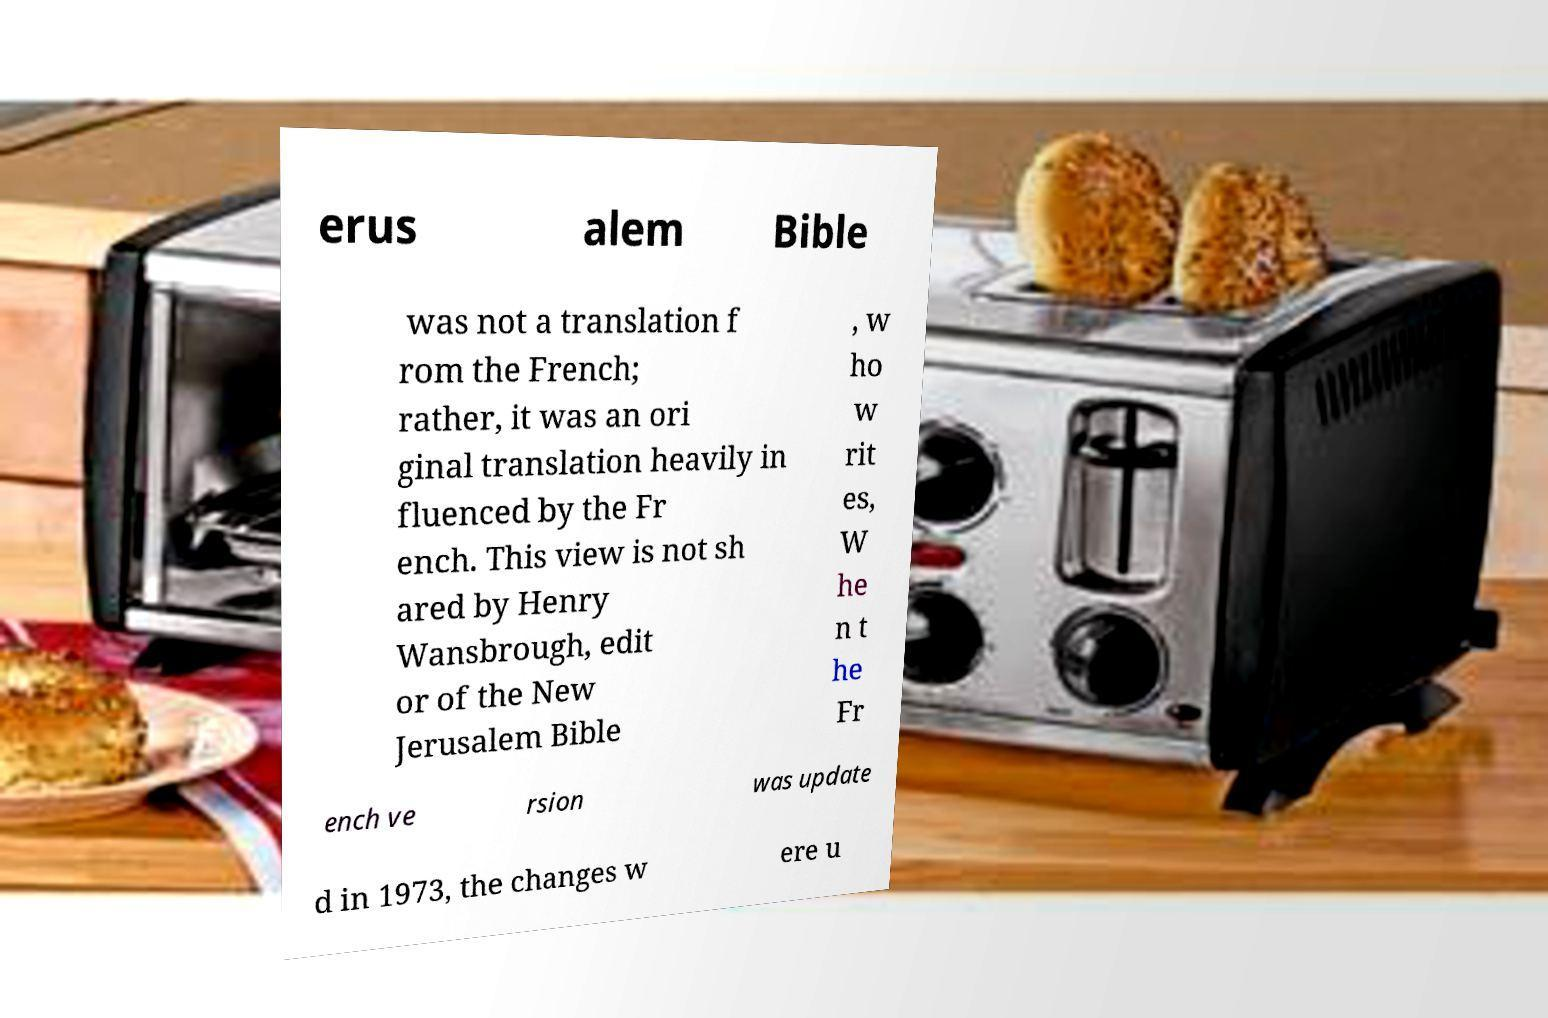Can you accurately transcribe the text from the provided image for me? erus alem Bible was not a translation f rom the French; rather, it was an ori ginal translation heavily in fluenced by the Fr ench. This view is not sh ared by Henry Wansbrough, edit or of the New Jerusalem Bible , w ho w rit es, W he n t he Fr ench ve rsion was update d in 1973, the changes w ere u 